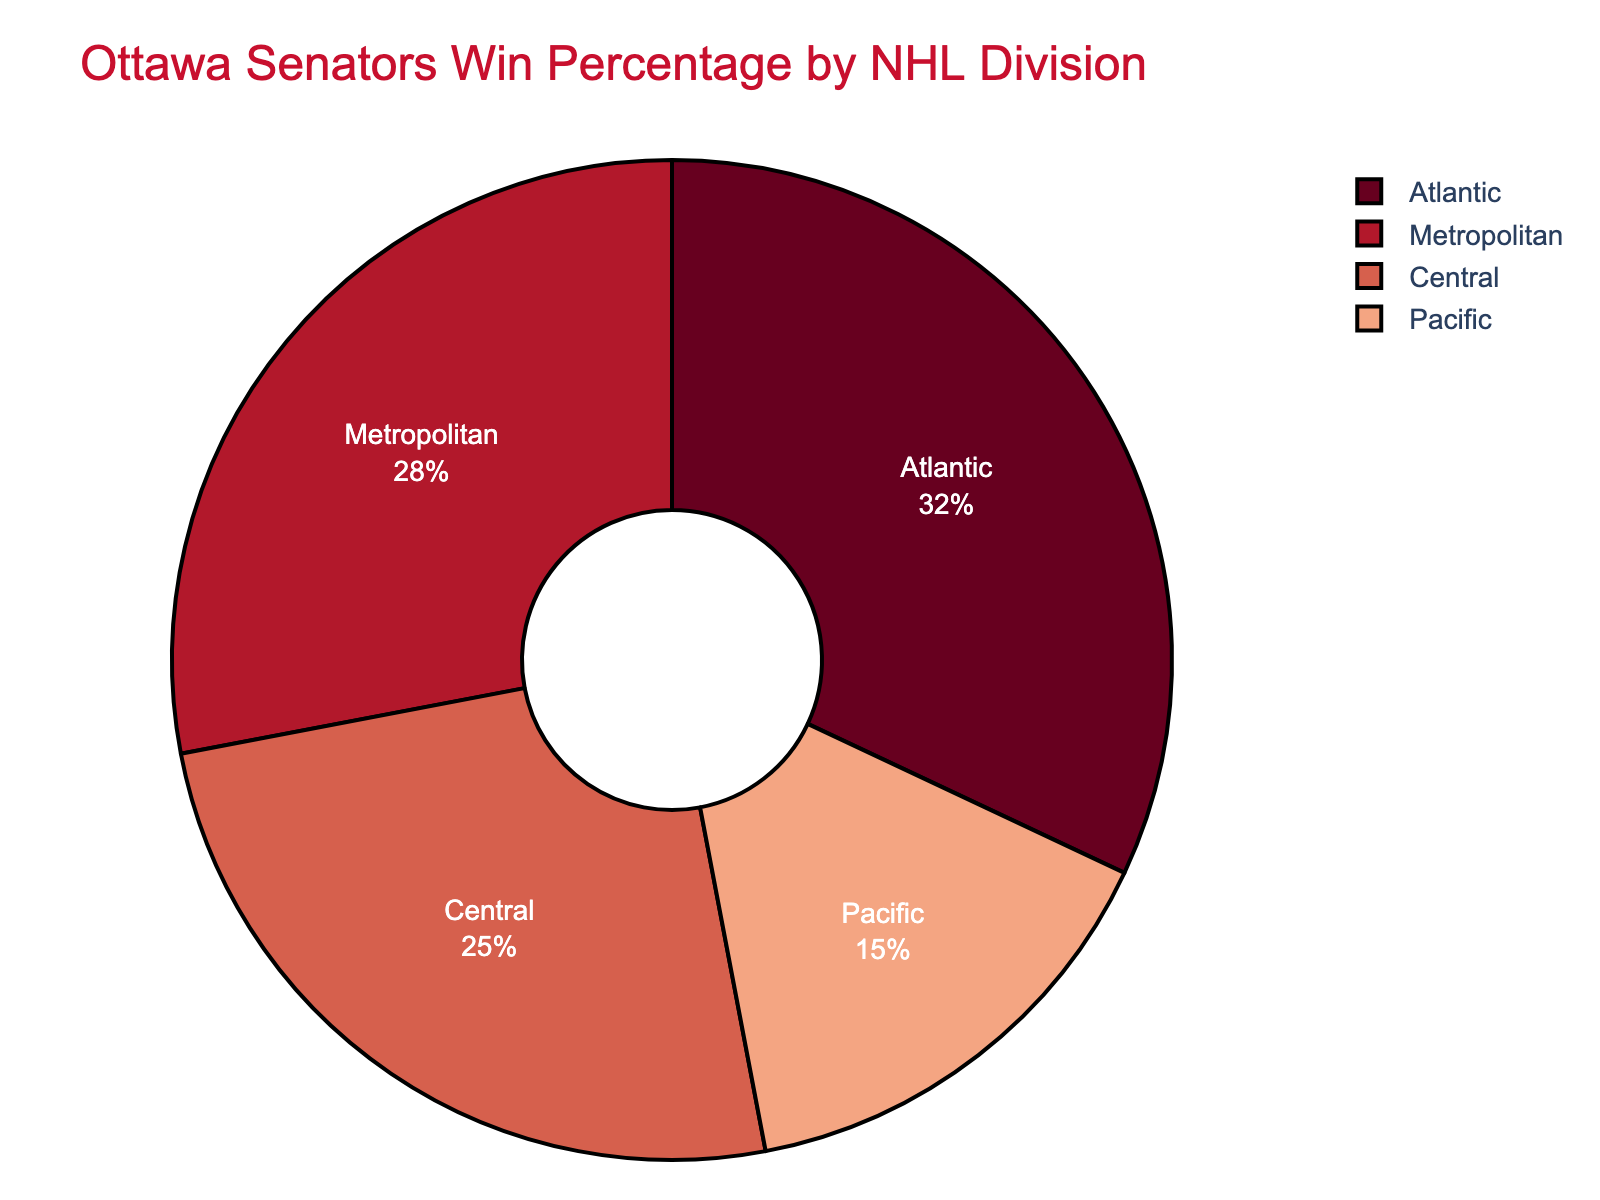Which division has the highest win percentage? The pie chart shows four divisions with different win percentages. The largest slice of the pie chart represents the Atlantic Division with 32%.
Answer: Atlantic Division How much higher is the win percentage of the Atlantic Division compared to the Pacific Division? The win percentage for the Atlantic Division is 32%, and for the Pacific Division, it is 15%. Subtract the Pacific percentage from the Atlantic percentage: 32% - 15% = 17%.
Answer: 17% Which two divisions combined make up more than half of the Ottawa Senators' wins? Add the win percentages of each division. Atlantic (32%) + Metropolitan (28%) = 60%, which is more than 50%.
Answer: Atlantic and Metropolitan What is the difference in win percentage between the division with the second-highest win percentage and the division with the lowest win percentage? The Metropolitan Division has the second-highest win percentage at 28%, and the Pacific Division has the lowest at 15%. The difference is 28% - 15% = 13%.
Answer: 13% What is the total win percentage for all divisions? Add up the win percentages of the four divisions: Atlantic (32%) + Metropolitan (28%) + Central (25%) + Pacific (15%) = 100%.
Answer: 100% Which division has the smallest slice in the pie chart? The pie chart visually shows that the Pacific Division has the smallest slice, representing 15% of the wins.
Answer: Pacific Division Are there any divisions with equal win percentages? The pie chart lists the win percentages for four divisions, none of which are equal: Atlantic (32%), Metropolitan (28%), Central (25%), and Pacific (15%).
Answer: No Which division's win percentage is closest to one quarter of the total percentage? One quarter of the total win percentage is 25%. The Central Division has a win percentage of 25%, which matches exactly.
Answer: Central Division How much less is the win percentage of the Central Division compared to the Atlantic Division? The win percentage of the Atlantic Division is 32%, and the Central Division is 25%. Subtracting 25% from 32% gives 32% - 25% = 7%.
Answer: 7% 